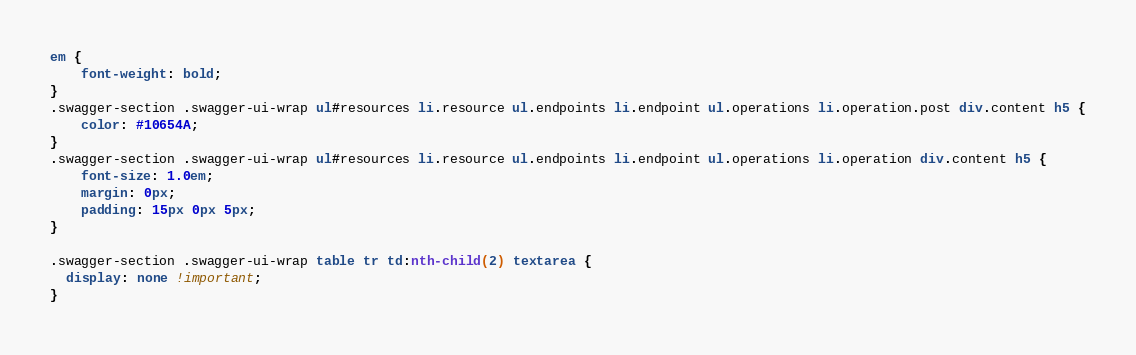<code> <loc_0><loc_0><loc_500><loc_500><_CSS_>

em {
    font-weight: bold;
}
.swagger-section .swagger-ui-wrap ul#resources li.resource ul.endpoints li.endpoint ul.operations li.operation.post div.content h5 {
    color: #10654A;
}
.swagger-section .swagger-ui-wrap ul#resources li.resource ul.endpoints li.endpoint ul.operations li.operation div.content h5 {
    font-size: 1.0em;
    margin: 0px;
    padding: 15px 0px 5px;
}

.swagger-section .swagger-ui-wrap table tr td:nth-child(2) textarea {
  display: none !important;
}
</code> 